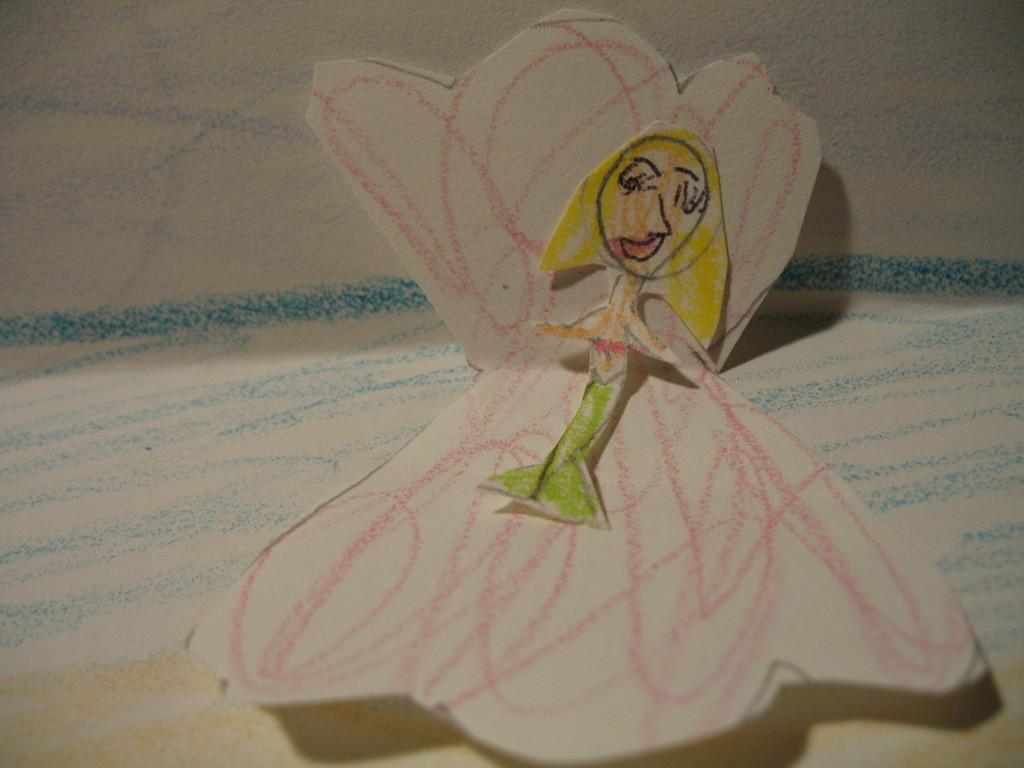What type of artwork is featured in the image? There are paper arts in the image. What can be found within the paper arts? The paper arts contain sketches. How many trees are visible in the image? There are no trees visible in the image; it features paper arts containing sketches. What type of oatmeal is being served in the image? There is no oatmeal present in the image. 